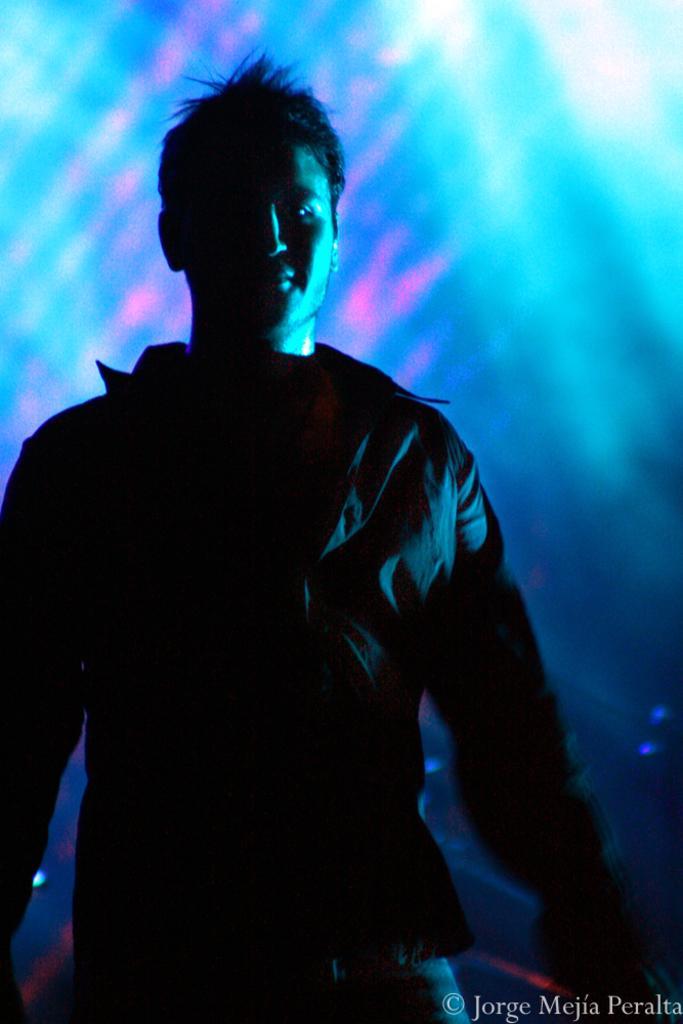In one or two sentences, can you explain what this image depicts? In the center of the image there is a person standing wearing a jacket. At the bottom of the image there is some text. 